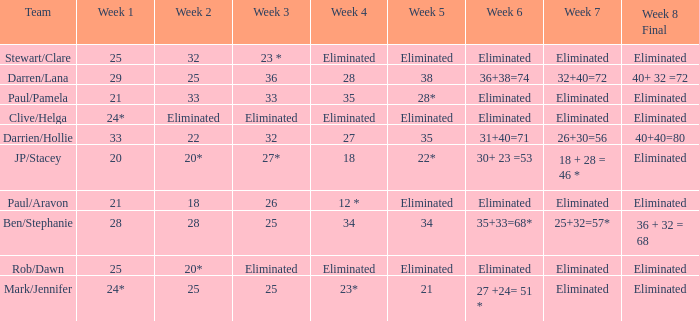Name the week 6 when week 3 is 25 and week 7 is eliminated 27 +24= 51 *. 